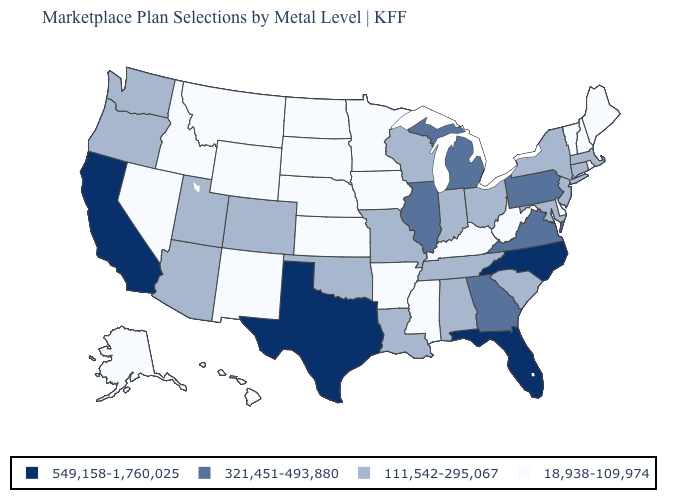What is the value of Indiana?
Quick response, please. 111,542-295,067. What is the value of Oklahoma?
Concise answer only. 111,542-295,067. Name the states that have a value in the range 111,542-295,067?
Be succinct. Alabama, Arizona, Colorado, Connecticut, Indiana, Louisiana, Maryland, Massachusetts, Missouri, New Jersey, New York, Ohio, Oklahoma, Oregon, South Carolina, Tennessee, Utah, Washington, Wisconsin. What is the value of North Dakota?
Answer briefly. 18,938-109,974. Which states have the lowest value in the MidWest?
Concise answer only. Iowa, Kansas, Minnesota, Nebraska, North Dakota, South Dakota. What is the value of Virginia?
Concise answer only. 321,451-493,880. Which states have the highest value in the USA?
Keep it brief. California, Florida, North Carolina, Texas. Which states have the lowest value in the West?
Concise answer only. Alaska, Hawaii, Idaho, Montana, Nevada, New Mexico, Wyoming. What is the lowest value in states that border Virginia?
Keep it brief. 18,938-109,974. Is the legend a continuous bar?
Give a very brief answer. No. Does Washington have a lower value than Alabama?
Concise answer only. No. What is the value of Wyoming?
Be succinct. 18,938-109,974. How many symbols are there in the legend?
Be succinct. 4. Does the first symbol in the legend represent the smallest category?
Answer briefly. No. Among the states that border South Carolina , does Georgia have the highest value?
Give a very brief answer. No. 